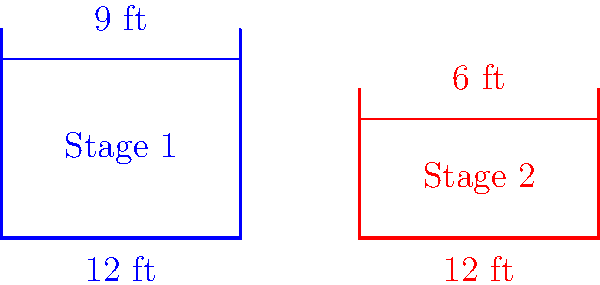You're planning two hip-hop concerts with different stage layouts. Stage 1 is rectangular with dimensions 12 ft by 9 ft, while Stage 2 is rectangular with dimensions 12 ft by 6 ft. Are these two stage layouts congruent? If not, explain why. To determine if the two stage layouts are congruent, we need to compare their shapes and sizes:

1. Shape: Both stages are rectangular, so they have the same shape.

2. Size: 
   - Stage 1: 12 ft × 9 ft
   - Stage 2: 12 ft × 6 ft

3. Congruence criteria for rectangles:
   Two rectangles are congruent if and only if they have the same length and width.

4. Comparison:
   - The length of both stages is the same (12 ft).
   - The width of Stage 1 (9 ft) is different from the width of Stage 2 (6 ft).

5. Conclusion:
   Since the widths are different, the two stage layouts are not congruent.

In the context of hip-hop performances, this difference in stage size could affect your performance style and crowd interaction. The larger Stage 1 might allow for more elaborate choreography or additional performers, while the smaller Stage 2 might create a more intimate setting.
Answer: Not congruent; different widths (9 ft vs 6 ft) 